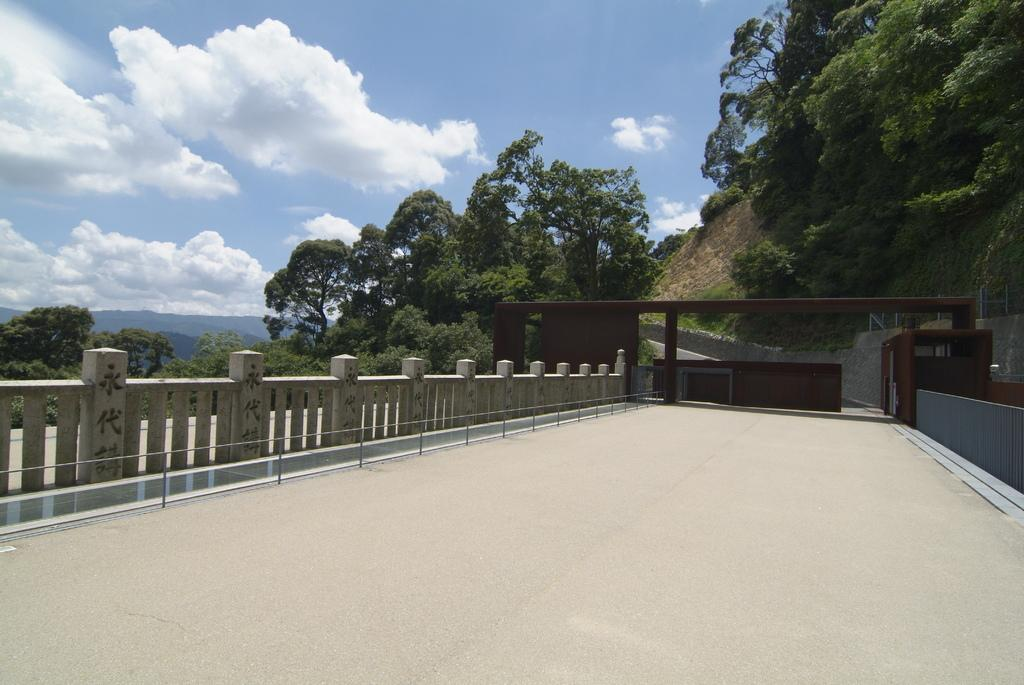What structure is the main subject of the image? There is a bridge in the image. What features can be observed on the bridge? The bridge has railings and an arch. What can be seen in the background of the image? There are trees in the background of the image. What is at the bottom of the image? There is a road at the bottom of the image. What is visible in the sky at the top of the image? There are clouds in the sky at the top of the image. What type of record is being played on the bridge in the image? There is no record or music player present in the image; it features a bridge with railings and an arch. What language is being spoken by the trees in the background of the image? Trees do not speak any language, and there is no indication of any language being spoken in the image. 